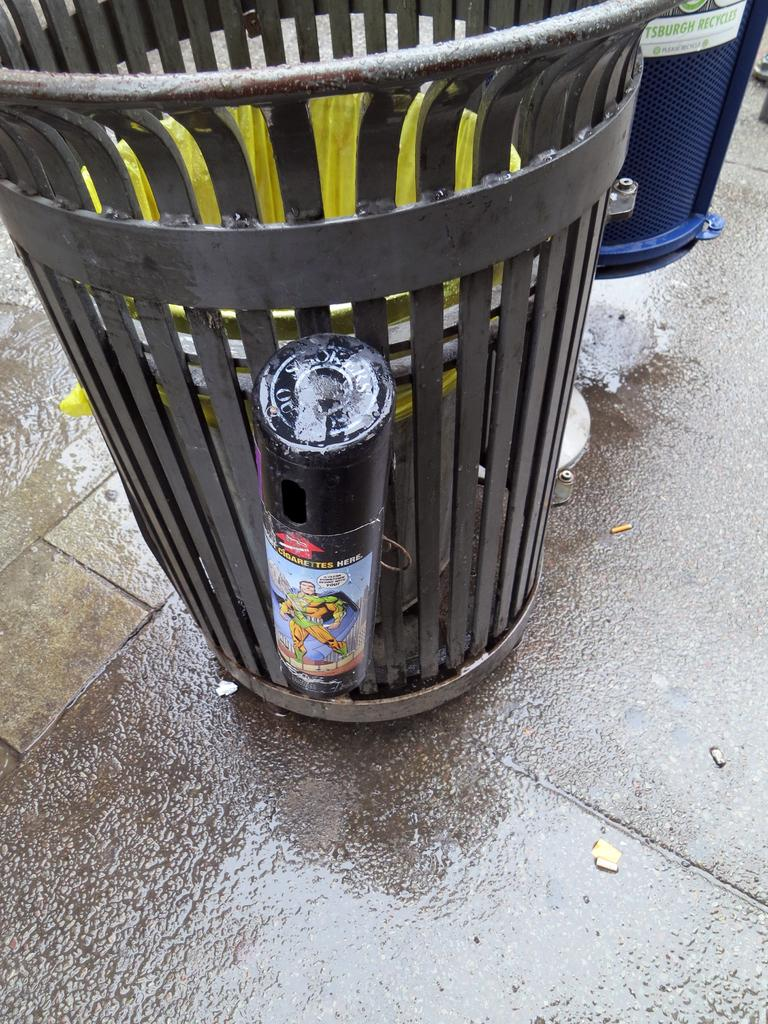What object can be seen in the image? There is a basket in the image. What type of milk is being poured into the basket in the image? There is no milk present in the image, as it only features a basket. What is the basket made of, and how does it feel to the touch? The image does not provide information about the material or texture of the basket, so it cannot be determined from the image. 